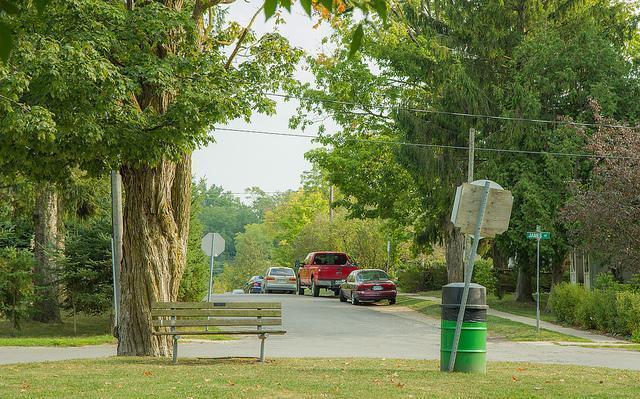What does the plaque on the back of this bench say?
Select the accurate answer and provide explanation: 'Answer: answer
Rationale: rationale.'
Options: Wet paint, bus ad, dedication, no seating. Answer: dedication.
Rationale: The plaque on the rear of the bench is a dedication. 